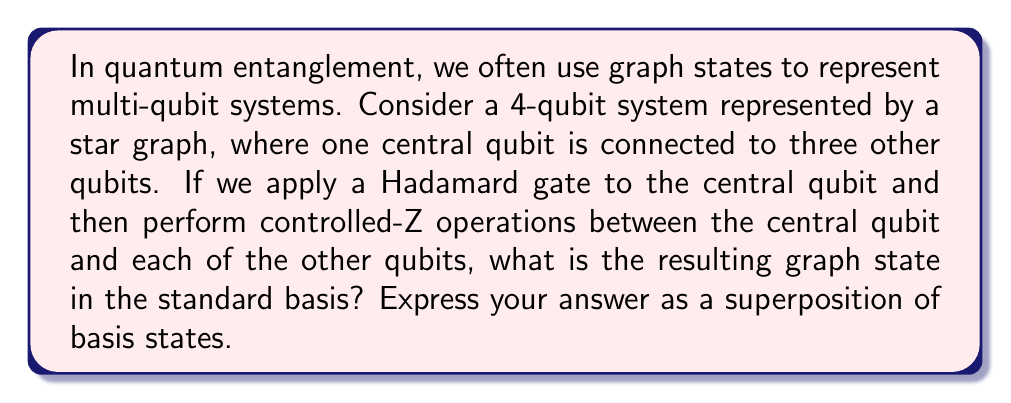Could you help me with this problem? To solve this problem, let's follow these steps:

1) First, let's understand the initial state. In a star graph with 4 qubits, we have:
   $$|ψ_0⟩ = |0000⟩$$

2) Applying a Hadamard gate (H) to the first qubit:
   $$H|0⟩ = \frac{1}{\sqrt{2}}(|0⟩ + |1⟩)$$
   So our state becomes:
   $$|ψ_1⟩ = \frac{1}{\sqrt{2}}(|0000⟩ + |1000⟩)$$

3) Now, we apply controlled-Z gates between the first qubit and each of the others. The controlled-Z gate leaves |00⟩ and |01⟩ unchanged, but adds a phase of -1 to |11⟩:
   $$CZ|00⟩ = |00⟩$$
   $$CZ|01⟩ = |01⟩$$
   $$CZ|10⟩ = |10⟩$$
   $$CZ|11⟩ = -|11⟩$$

4) Applying this to our state:
   $$|ψ_2⟩ = \frac{1}{\sqrt{2}}(|0000⟩ - |1111⟩)$$

5) This is our final graph state. It's a maximally entangled state known as the GHZ state for 4 qubits.
Answer: $$|ψ_{\text{final}}⟩ = \frac{1}{\sqrt{2}}(|0000⟩ - |1111⟩)$$ 